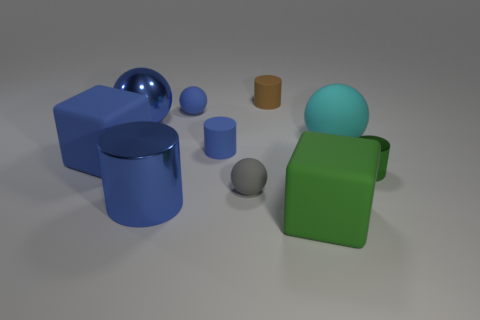There is a green thing in front of the green cylinder; is its size the same as the big cylinder?
Ensure brevity in your answer.  Yes. Is the material of the large cube behind the large green thing the same as the green thing that is in front of the small gray rubber thing?
Make the answer very short. Yes. Is there another cylinder of the same size as the blue metallic cylinder?
Keep it short and to the point. No. What shape is the big shiny thing that is right of the large shiny thing behind the large cube left of the blue matte ball?
Provide a succinct answer. Cylinder. Is the number of green metallic cylinders that are in front of the tiny gray rubber object greater than the number of big spheres?
Provide a succinct answer. No. Is there a green shiny thing that has the same shape as the tiny brown object?
Give a very brief answer. Yes. Are the blue cube and the tiny ball that is to the right of the small blue matte cylinder made of the same material?
Make the answer very short. Yes. The metallic sphere is what color?
Your response must be concise. Blue. There is a big sphere that is in front of the blue metal thing that is left of the big cylinder; what number of large metallic objects are behind it?
Provide a short and direct response. 1. Are there any matte things to the right of the small brown object?
Provide a succinct answer. Yes. 